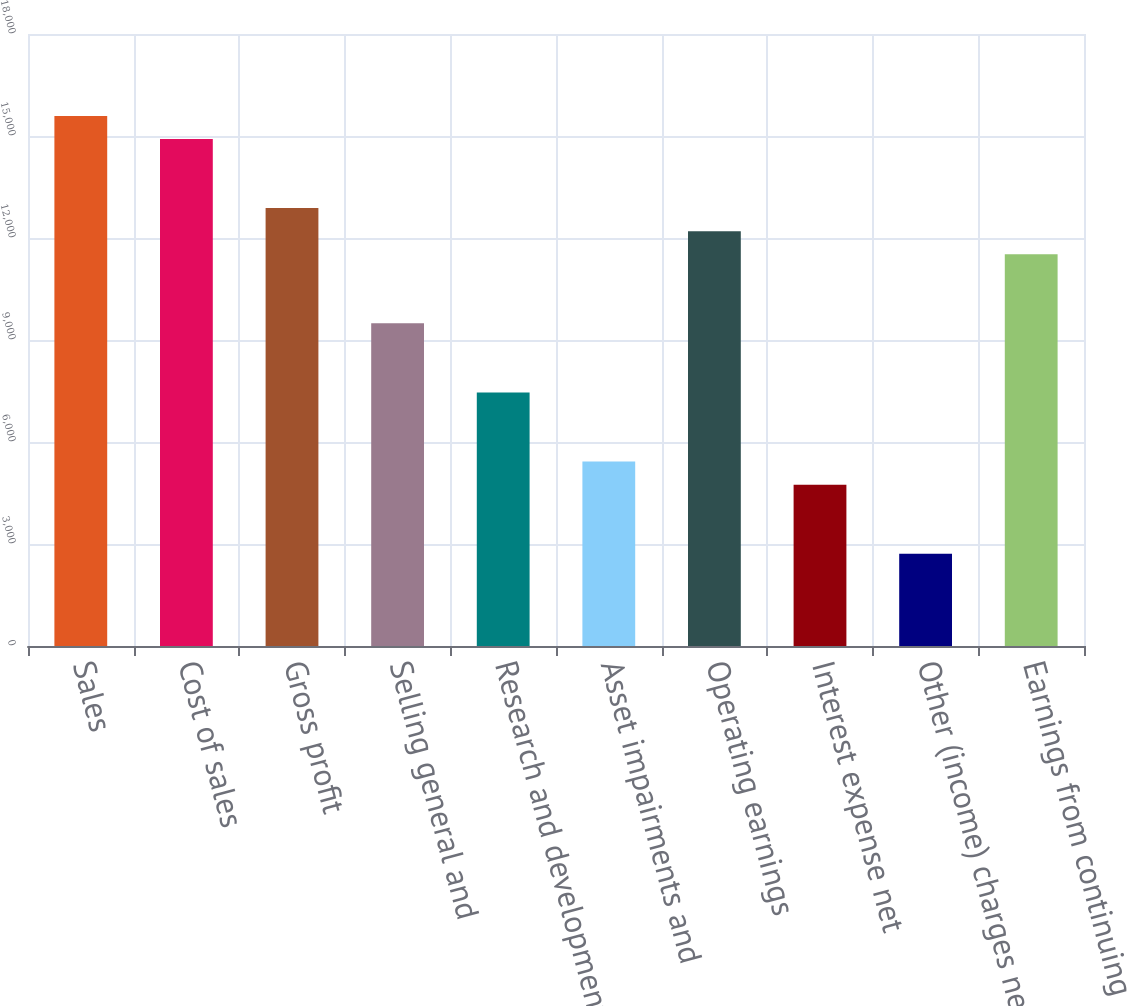Convert chart. <chart><loc_0><loc_0><loc_500><loc_500><bar_chart><fcel>Sales<fcel>Cost of sales<fcel>Gross profit<fcel>Selling general and<fcel>Research and development<fcel>Asset impairments and<fcel>Operating earnings<fcel>Interest expense net<fcel>Other (income) charges net<fcel>Earnings from continuing<nl><fcel>15591.5<fcel>14913.6<fcel>12879.9<fcel>9490.54<fcel>7456.9<fcel>5423.26<fcel>12202.1<fcel>4745.38<fcel>2711.74<fcel>11524.2<nl></chart> 